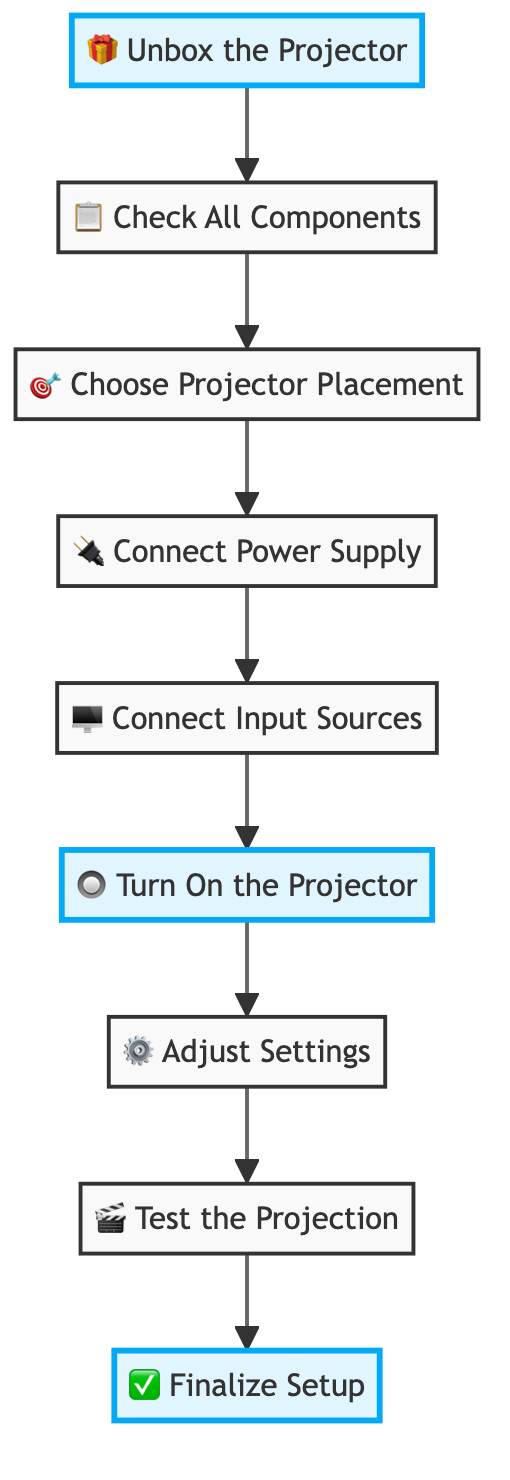What is the first step in the projector setup process? The first step in the setup process is indicated by the starting node labeled "Unbox the Projector." It is at the top of the flow chart, leading to the next step.
Answer: Unbox the Projector How many steps are there in total in the setup process? By counting all the nodes connected in the flow chart, including the starting and ending nodes, there are a total of 8 steps in the setup process.
Answer: 8 Which step follows "Connect Power Supply"? The step that follows "Connect Power Supply" is "Connect Input Sources." This can be determined by tracing the arrows from the "Connect Power Supply" node to the next connected node.
Answer: Connect Input Sources What symbols are used to highlight key steps? The highlighted key steps in the flow chart are represented by the icons of a gift box, a power button, and a checkmark. These are visually distinct from the other steps through a different background color and increased font weight.
Answer: Gift box, power button, checkmark Which steps are highlighted nodes in the diagram? The highlighted nodes in the diagram are "Unbox the Projector," "Turn On the Projector," and "Finalize Setup." These nodes have additional emphasis in the flow chart compared to others.
Answer: Unbox the Projector, Turn On the Projector, Finalize Setup What is the relationship between "Adjust Settings" and "Test the Projection"? "Adjust Settings" precedes "Test the Projection." In the flow chart, there is a connecting arrow that shows the flow from "Adjust Settings" to "Test the Projection," indicating that settings must be adjusted before testing can occur.
Answer: Precedes What is the last step in the setup process? The last step is indicated at the end of the flow chart, which is labeled "Finalize Setup." This is where all previous steps lead to a conclusion.
Answer: Finalize Setup What is the action in the "Turn On the Projector" step? The action described in this step is "Press the power button to turn on the projector and check the indicator lights," which is a specific instruction regarding the operation of the projector.
Answer: Press the power button How does the diagram depict the sequential flow of setup steps? The sequential flow is depicted through directed arrows connecting each step, showing the order of actions required from unboxing the projector to finalizing the setup. This illustrates a clear path of actions in the setup process.
Answer: Directed arrows 